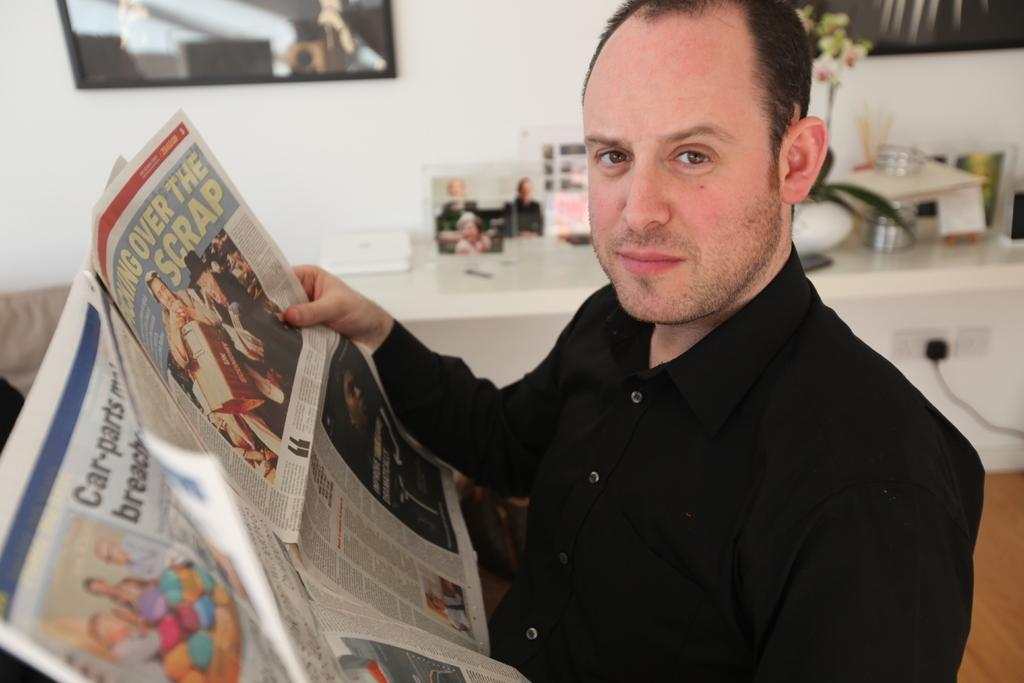<image>
Write a terse but informative summary of the picture. A man is reading a newspaper that has the word "scrap" in one of the headlines. 